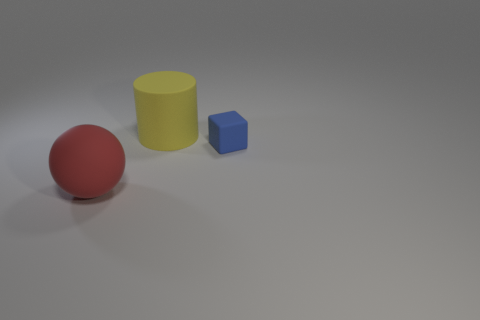Add 2 spheres. How many objects exist? 5 Subtract all cyan cylinders. Subtract all brown balls. How many cylinders are left? 1 Subtract all cylinders. How many objects are left? 2 Add 2 cylinders. How many cylinders exist? 3 Subtract 0 yellow balls. How many objects are left? 3 Subtract all rubber blocks. Subtract all large cyan metal cubes. How many objects are left? 2 Add 1 big matte cylinders. How many big matte cylinders are left? 2 